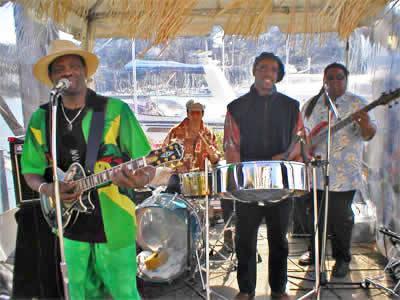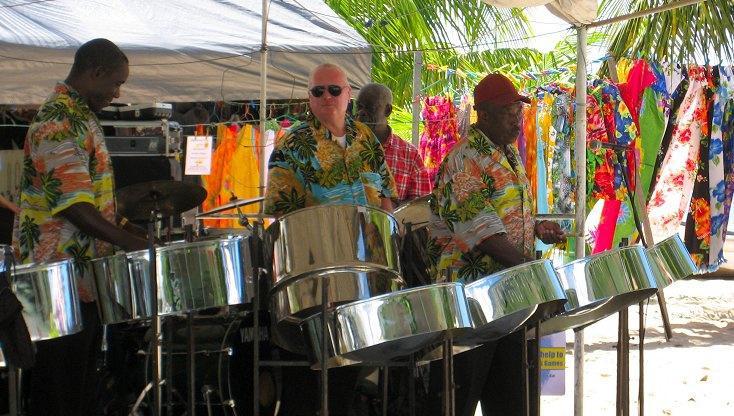The first image is the image on the left, the second image is the image on the right. Examine the images to the left and right. Is the description "In one image all the musicians are wearing hats." accurate? Answer yes or no. No. The first image is the image on the left, the second image is the image on the right. Examine the images to the left and right. Is the description "One image features three men in hats and leis and hawaiian shirts standing behind silver metal drums on pivoting stands." accurate? Answer yes or no. No. 